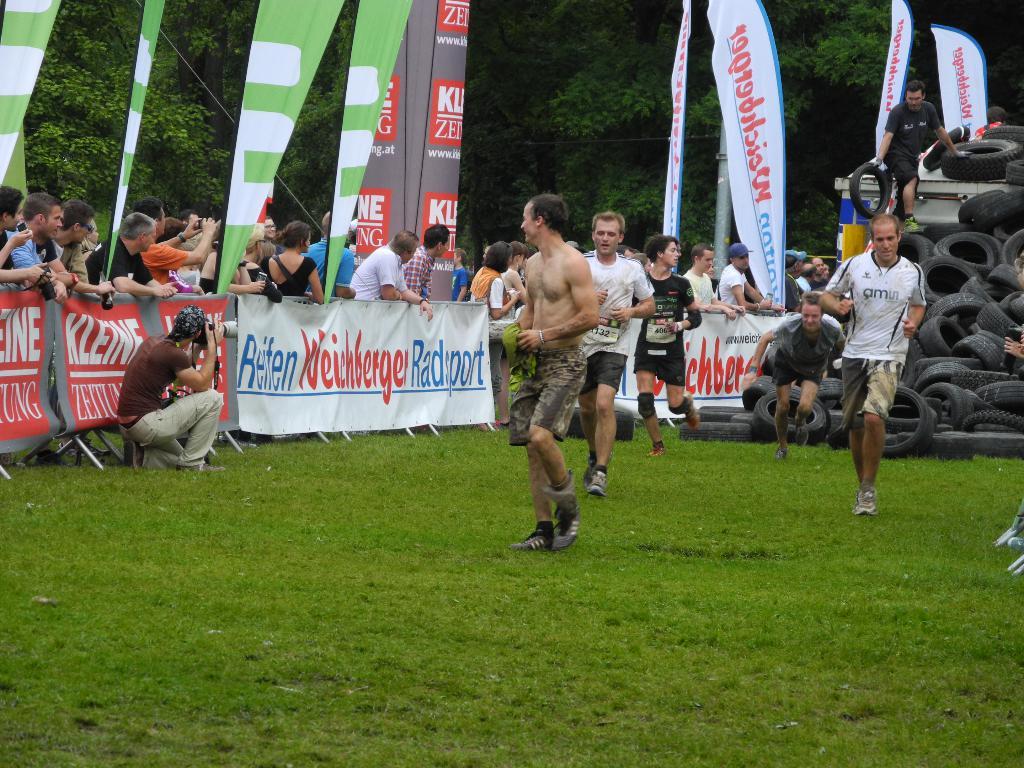What is on the man's shirt on the right?
Ensure brevity in your answer.  Amn. 